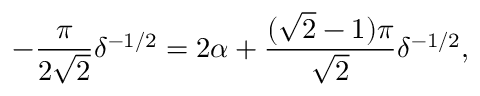Convert formula to latex. <formula><loc_0><loc_0><loc_500><loc_500>- \frac { \pi } { 2 \sqrt { 2 } } \delta ^ { - 1 / 2 } = 2 \alpha + \frac { ( \sqrt { 2 } - 1 ) \pi } { \sqrt { 2 } } \delta ^ { - 1 / 2 } ,</formula> 